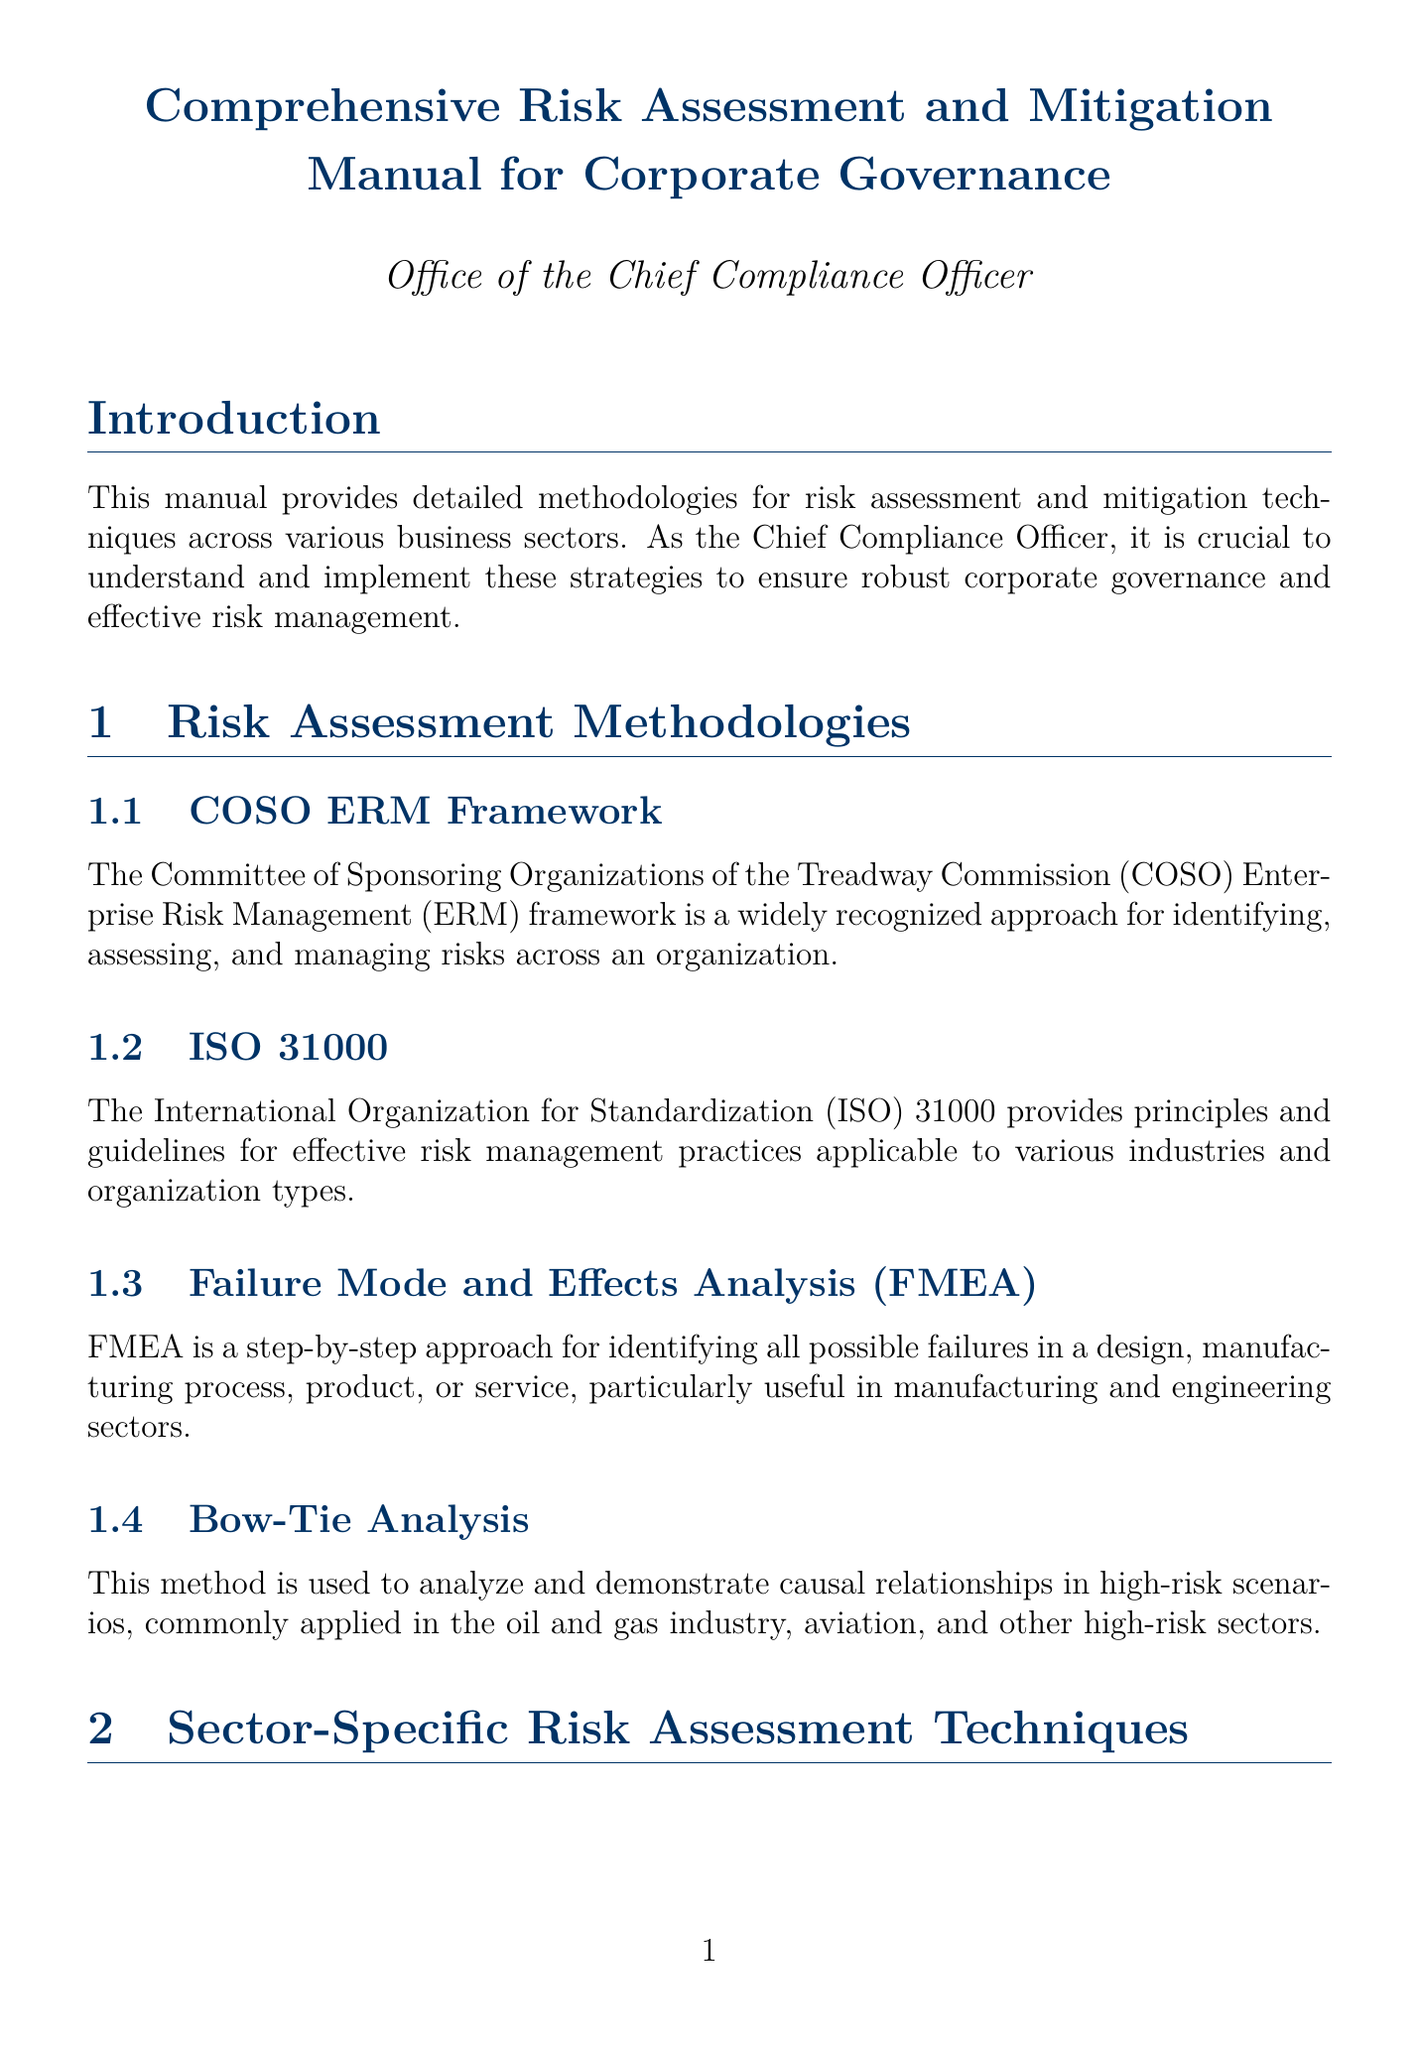What is the title of the manual? The title is clearly indicated in the document's heading.
Answer: Comprehensive Risk Assessment and Mitigation Manual for Corporate Governance What is the framework mentioned in the Risk Assessment Methodologies section? COSO ERM Framework is listed as a key methodology in this section.
Answer: COSO ERM Framework Which sector utilizes HIPAA risk assessments? This detail is outlined in the sector-specific risk assessment techniques section regarding healthcare.
Answer: Healthcare What are the four risk mitigation techniques listed? These techniques are specifically categorized under risk mitigation techniques in the document content.
Answer: Risk Avoidance, Risk Reduction, Risk Transfer, Risk Acceptance What does ESG stand for in the Regulatory Compliance and Reporting section? ESG is an acronym defined in the compliance and reporting guidelines, representing a specific framework.
Answer: Environmental, Social, and Governance What is the purpose of the Risk Appetite Statement? The document mentions this process in the context of risk management, detailing its significance.
Answer: Define and document the organization's willingness to accept risk Which risk management software is mentioned? The document gives examples of platforms recommended for implementation in risk management.
Answer: MetricStream, LogicManager, SAP Risk Management What is the key focus of Key Risk Indicators (KRIs)? Guidance on KRIs is provided that explains their role in risk management monitoring.
Answer: Early warnings of increasing risk exposures What technique is used to analyze causal relationships in high-risk scenarios? Bow-Tie Analysis is specifically mentioned for this purpose.
Answer: Bow-Tie Analysis 